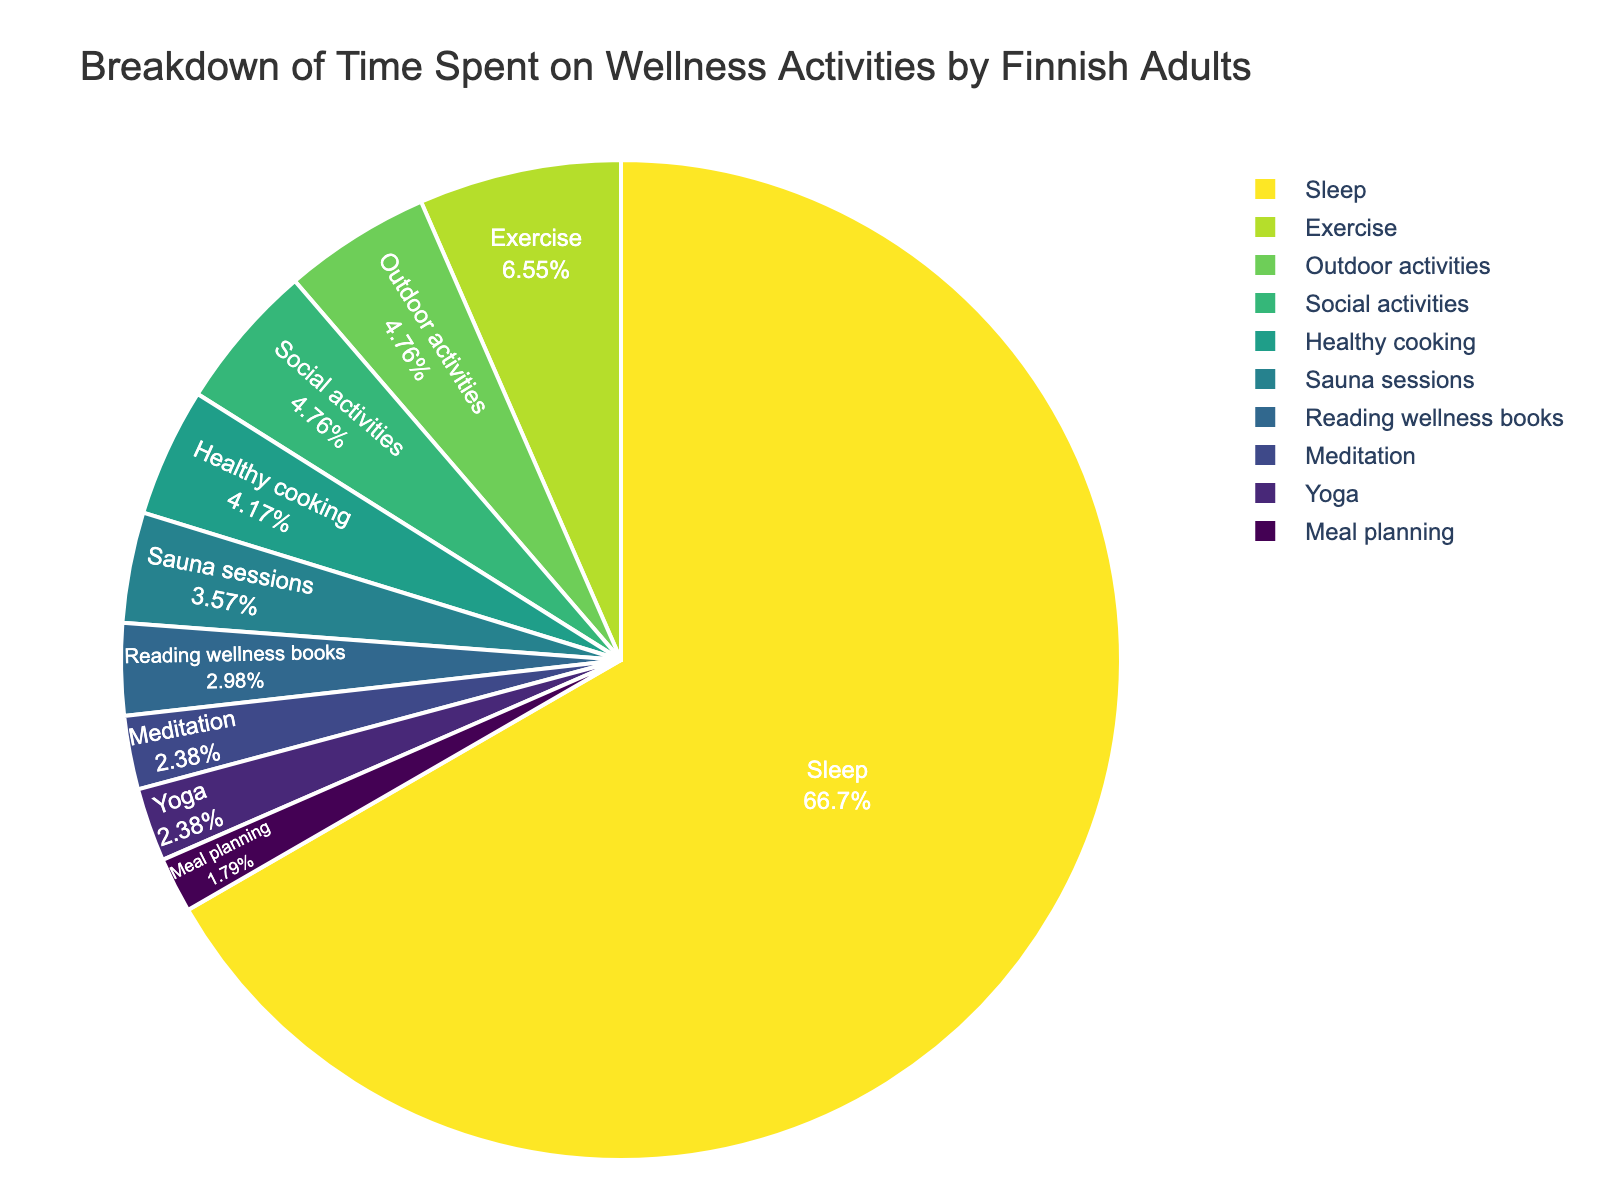What's the largest category in terms of time spent? Looking at the pie chart, the largest slice represents 'Sleep.' It accounts for the highest percentage of time spent on wellness activities.
Answer: Sleep How much more time is spent on exercise compared to meditation? The pie chart shows that Finnish adults spend 5.5 hours per week on exercise and 2.0 hours per week on meditation. The difference is 5.5 - 2.0 = 3.5 hours.
Answer: 3.5 hours Which activities each account for more than 10% of the total time spent? By examining the portions of the pie chart, the activities that each represent more than 10% are 'Sleep' as it dominates the chart, being the largest section. No other slices seem to exceed 10%.
Answer: Sleep Compare the combined time spent on outdoor activities and social activities versus exercise. Which is greater? The pie chart shows outdoor activities at 4.0 hours and social activities at 4.0 hours, making a combined total of 4.0 + 4.0 = 8.0 hours. Exercise is 5.5 hours. Therefore, 8.0 hours (outdoor + social) is greater than 5.5 hours (exercise).
Answer: Outdoor and social activities What proportion of time is spent on sauna sessions relative to healthy cooking? The chart indicates 3.0 hours for sauna sessions and 3.5 hours for healthy cooking. The proportion is 3.0 / 3.5, which simplifies to approximately 0.857.
Answer: Approximately 0.857 What is the combined percentage of time spent on meditation and yoga? According to the pie chart, time spent on meditation is 2.0 hours per week, and yoga is also 2.0 hours per week. Combine them to get 2.0 + 2.0 = 4.0 hours. Calculate the percentage by (4.0 / total hours) * 100. The total hours are the sum of all activities (79.0 hours). So, (4.0 / 79.0) * 100 ≈ 5.06%.
Answer: Approximately 5.06% Is the time spent on social activities greater than the time spent on healthy cooking? As shown in the pie chart, social activities account for 4.0 hours per week, whereas healthy cooking accounts for 3.5 hours per week. Therefore, social activities have more time dedicated to them.
Answer: Yes How does the time spent on meal planning compare to the time spent on reading wellness books? The pie chart indicates meal planning at 1.5 hours per week and reading wellness books at 2.5 hours per week. Consequently, reading wellness books has more hours dedicated to it.
Answer: Reading wellness books What is the ratio of time spent on exercise to the total wellness activities? The total number of hours spent on wellness activities is 79.0. The hours spent on exercise are 5.5. Therefore, the ratio is 5.5 / 79.0, which simplifies to approximately 0.07.
Answer: Approximately 0.07 Which activity uses a similar amount of time as healthy cooking? By studying the pie chart, it's clear that the activity with a similar time allocation to healthy cooking (3.5 hours) is 'Outdoor activities,' which also uses 4.0 hours per week.
Answer: Outdoor activities 